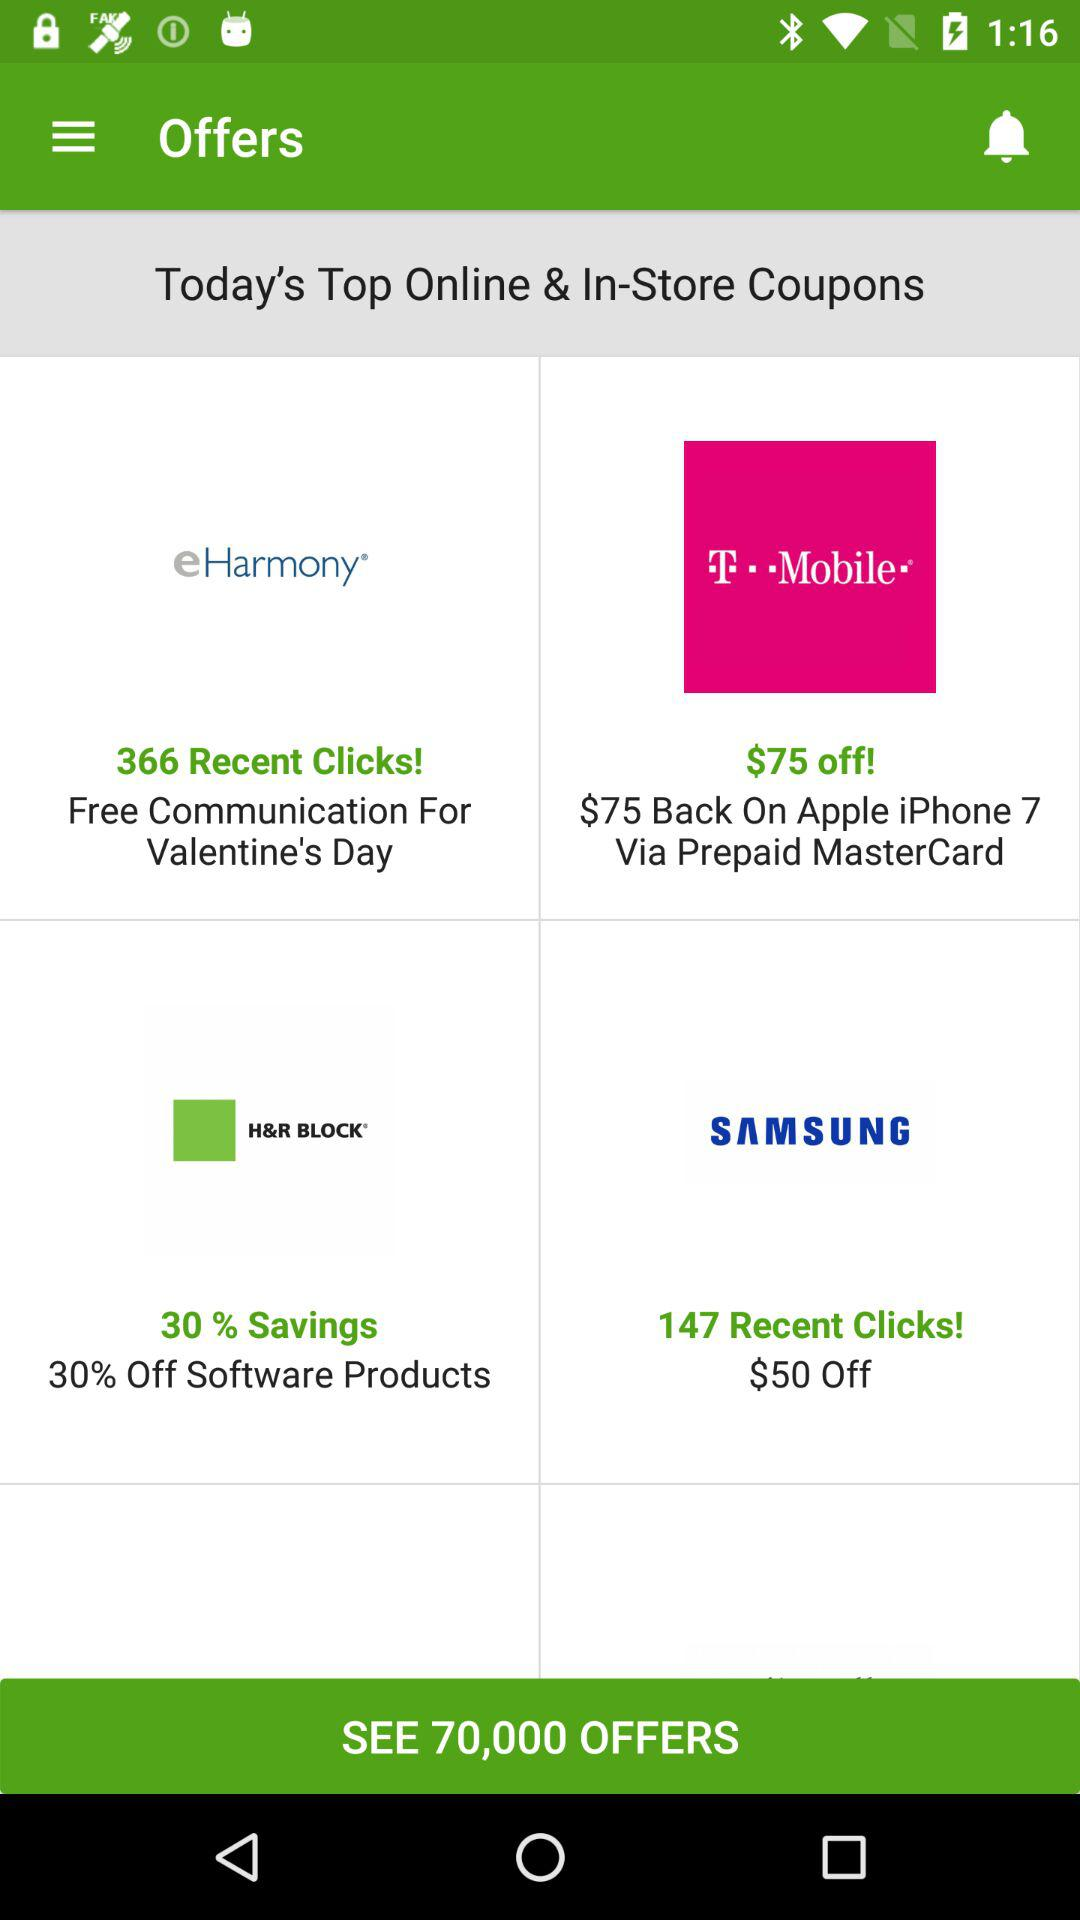How many discounts are on software products? There is a discount of 30% on software products. 